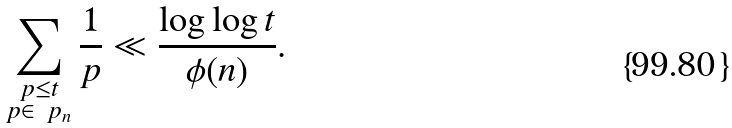<formula> <loc_0><loc_0><loc_500><loc_500>\sum _ { \substack { p \leq t \\ p \in \ p _ { n } } } \frac { 1 } { p } \ll \frac { \log \log t } { \phi ( n ) } .</formula> 